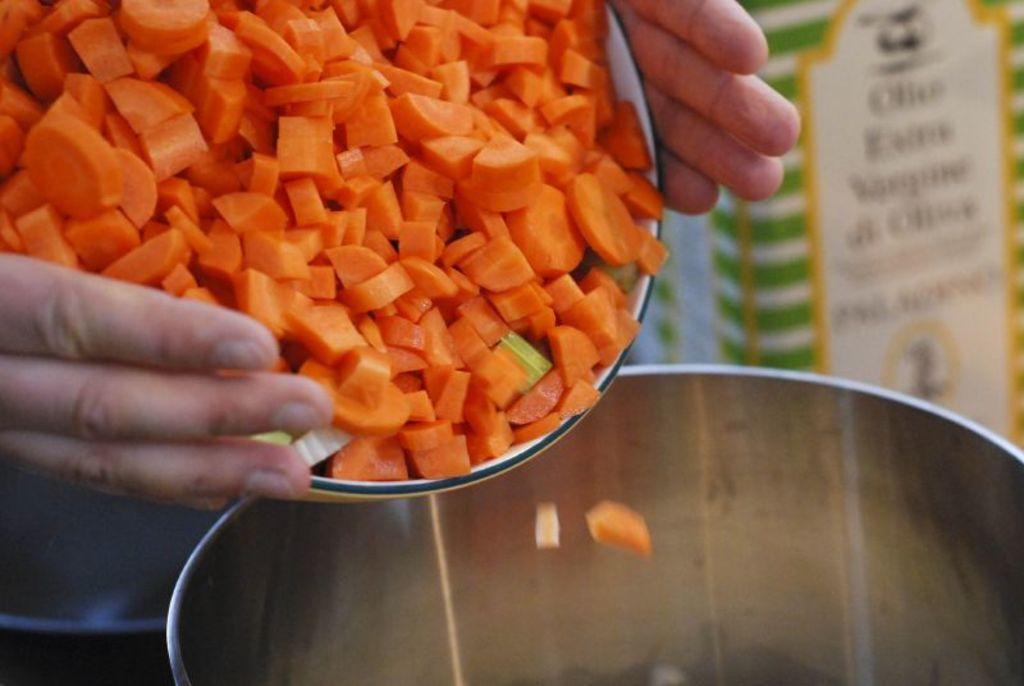Can you describe this image briefly? In this image, we can see a human hands holding a bowl with chopped carrots and trying to pour into another container. Background there is a blur view. Here we can see some box. 